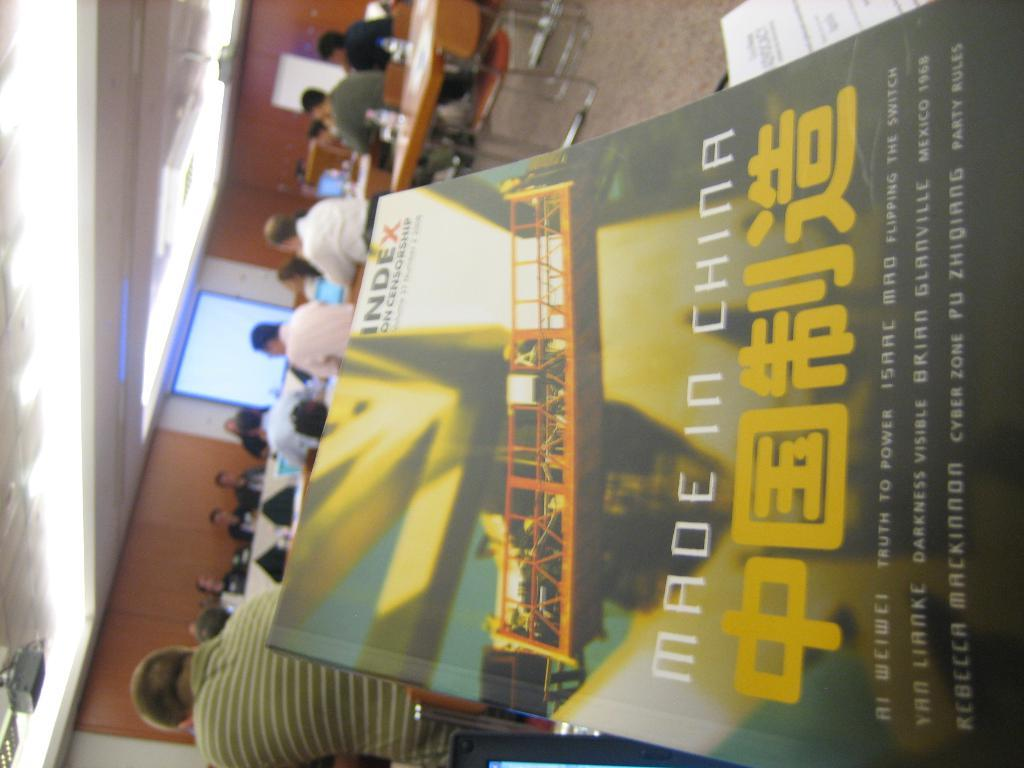<image>
Offer a succinct explanation of the picture presented. a book that says index on the top right corner of it 